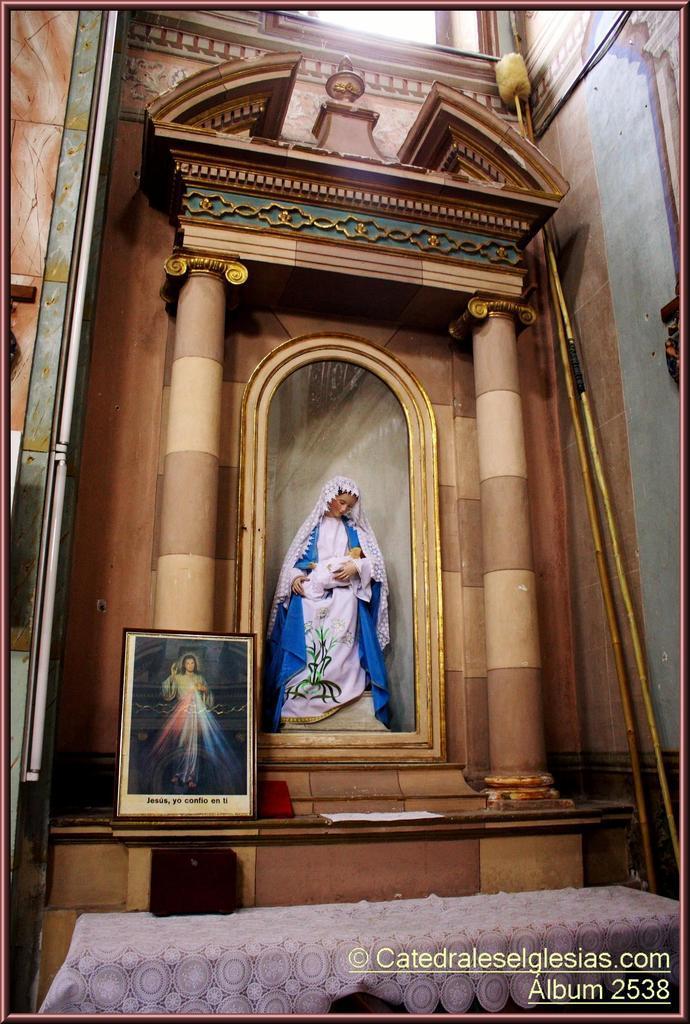Describe this image in one or two sentences. This image is taken in the church. In this image we can see the idol in the center. We can also see the frame, paper, sticks, wall, window and at the bottom we can see the table which is covered with the cloth. We can also see the text and the image has borders. We can also see the lights on the left. 